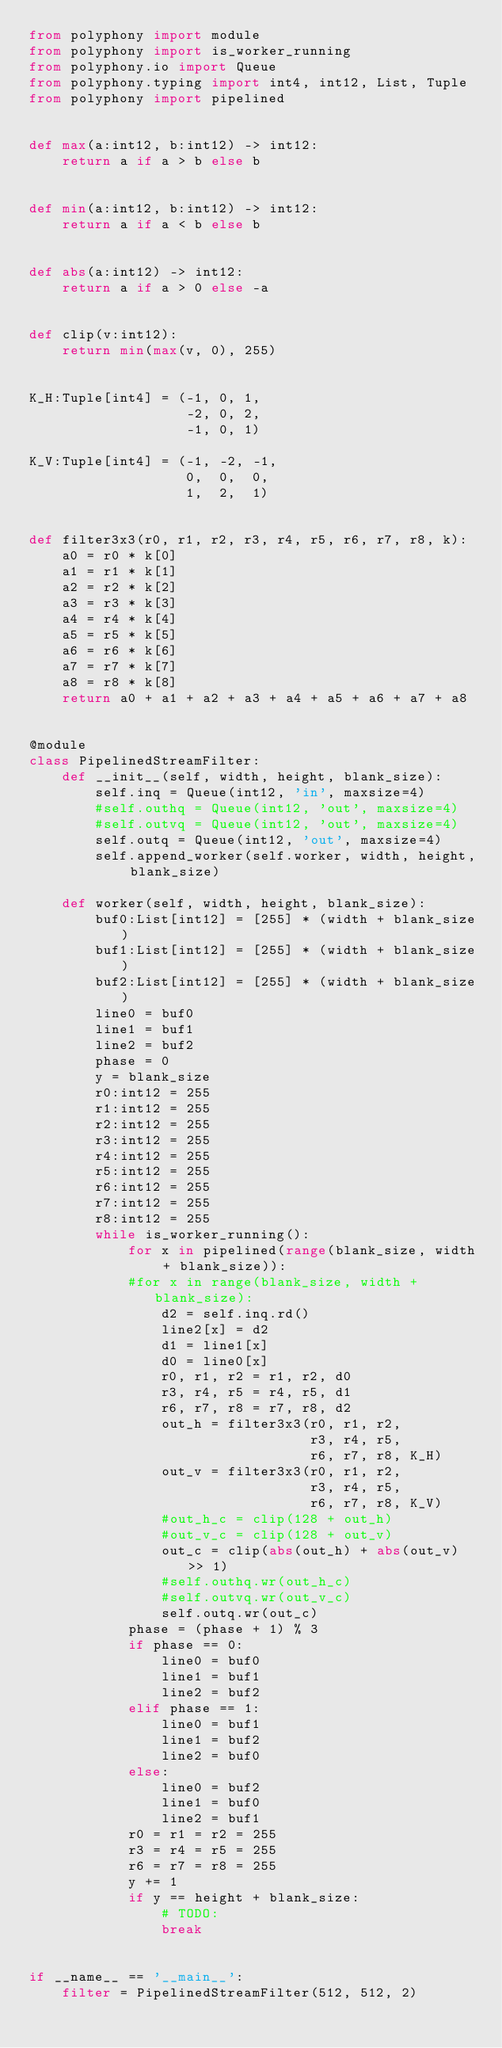<code> <loc_0><loc_0><loc_500><loc_500><_Python_>from polyphony import module
from polyphony import is_worker_running
from polyphony.io import Queue
from polyphony.typing import int4, int12, List, Tuple
from polyphony import pipelined


def max(a:int12, b:int12) -> int12:
    return a if a > b else b


def min(a:int12, b:int12) -> int12:
    return a if a < b else b


def abs(a:int12) -> int12:
    return a if a > 0 else -a


def clip(v:int12):
    return min(max(v, 0), 255)


K_H:Tuple[int4] = (-1, 0, 1,
                   -2, 0, 2,
                   -1, 0, 1)

K_V:Tuple[int4] = (-1, -2, -1,
                   0,  0,  0,
                   1,  2,  1)


def filter3x3(r0, r1, r2, r3, r4, r5, r6, r7, r8, k):
    a0 = r0 * k[0]
    a1 = r1 * k[1]
    a2 = r2 * k[2]
    a3 = r3 * k[3]
    a4 = r4 * k[4]
    a5 = r5 * k[5]
    a6 = r6 * k[6]
    a7 = r7 * k[7]
    a8 = r8 * k[8]
    return a0 + a1 + a2 + a3 + a4 + a5 + a6 + a7 + a8


@module
class PipelinedStreamFilter:
    def __init__(self, width, height, blank_size):
        self.inq = Queue(int12, 'in', maxsize=4)
        #self.outhq = Queue(int12, 'out', maxsize=4)
        #self.outvq = Queue(int12, 'out', maxsize=4)
        self.outq = Queue(int12, 'out', maxsize=4)
        self.append_worker(self.worker, width, height, blank_size)

    def worker(self, width, height, blank_size):
        buf0:List[int12] = [255] * (width + blank_size)
        buf1:List[int12] = [255] * (width + blank_size)
        buf2:List[int12] = [255] * (width + blank_size)
        line0 = buf0
        line1 = buf1
        line2 = buf2
        phase = 0
        y = blank_size
        r0:int12 = 255
        r1:int12 = 255
        r2:int12 = 255
        r3:int12 = 255
        r4:int12 = 255
        r5:int12 = 255
        r6:int12 = 255
        r7:int12 = 255
        r8:int12 = 255
        while is_worker_running():
            for x in pipelined(range(blank_size, width + blank_size)):
            #for x in range(blank_size, width + blank_size):
                d2 = self.inq.rd()
                line2[x] = d2
                d1 = line1[x]
                d0 = line0[x]
                r0, r1, r2 = r1, r2, d0
                r3, r4, r5 = r4, r5, d1
                r6, r7, r8 = r7, r8, d2
                out_h = filter3x3(r0, r1, r2,
                                  r3, r4, r5,
                                  r6, r7, r8, K_H)
                out_v = filter3x3(r0, r1, r2,
                                  r3, r4, r5,
                                  r6, r7, r8, K_V)
                #out_h_c = clip(128 + out_h)
                #out_v_c = clip(128 + out_v)
                out_c = clip(abs(out_h) + abs(out_v) >> 1)
                #self.outhq.wr(out_h_c)
                #self.outvq.wr(out_v_c)
                self.outq.wr(out_c)
            phase = (phase + 1) % 3
            if phase == 0:
                line0 = buf0
                line1 = buf1
                line2 = buf2
            elif phase == 1:
                line0 = buf1
                line1 = buf2
                line2 = buf0
            else:
                line0 = buf2
                line1 = buf0
                line2 = buf1
            r0 = r1 = r2 = 255
            r3 = r4 = r5 = 255
            r6 = r7 = r8 = 255
            y += 1
            if y == height + blank_size:
                # TODO:
                break


if __name__ == '__main__':
    filter = PipelinedStreamFilter(512, 512, 2)
</code> 